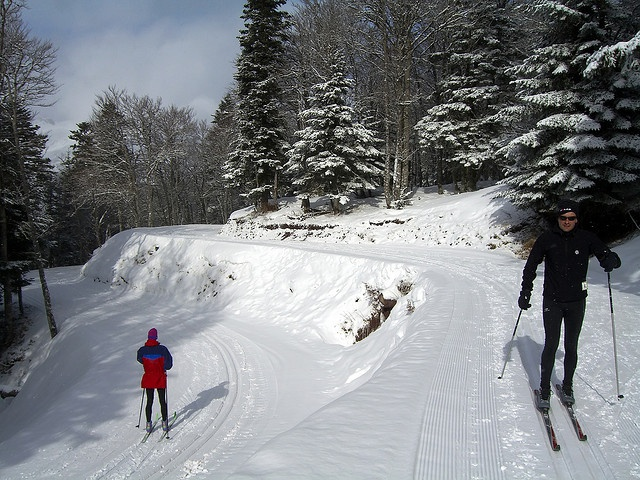Describe the objects in this image and their specific colors. I can see people in gray, black, maroon, and brown tones, people in gray, black, maroon, and navy tones, skis in gray, black, and darkgray tones, and skis in gray, darkgray, and black tones in this image. 